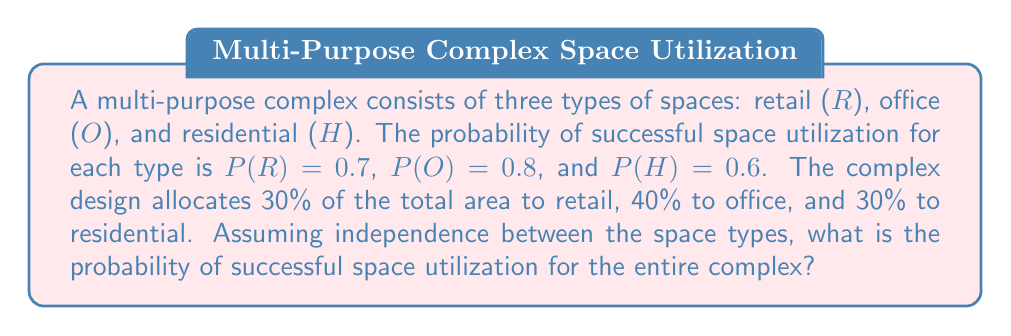Help me with this question. To solve this problem, we need to follow these steps:

1) First, we recognize that the success of the entire complex depends on the weighted average of the success probabilities of each space type.

2) We can use the formula for the total probability:

   $$P(\text{Success}) = w_R \cdot P(R) + w_O \cdot P(O) + w_H \cdot P(H)$$

   where $w_R$, $w_O$, and $w_H$ are the weights (proportions) of each space type.

3) We know the following:
   - $w_R = 0.30$ (30% retail)
   - $w_O = 0.40$ (40% office)
   - $w_H = 0.30$ (30% residential)
   - $P(R) = 0.7$
   - $P(O) = 0.8$
   - $P(H) = 0.6$

4) Now, let's substitute these values into our formula:

   $$P(\text{Success}) = 0.30 \cdot 0.7 + 0.40 \cdot 0.8 + 0.30 \cdot 0.6$$

5) Let's calculate each term:
   - $0.30 \cdot 0.7 = 0.21$
   - $0.40 \cdot 0.8 = 0.32$
   - $0.30 \cdot 0.6 = 0.18$

6) Now, we sum these values:

   $$P(\text{Success}) = 0.21 + 0.32 + 0.18 = 0.71$$

Therefore, the probability of successful space utilization for the entire complex is 0.71 or 71%.
Answer: 0.71 